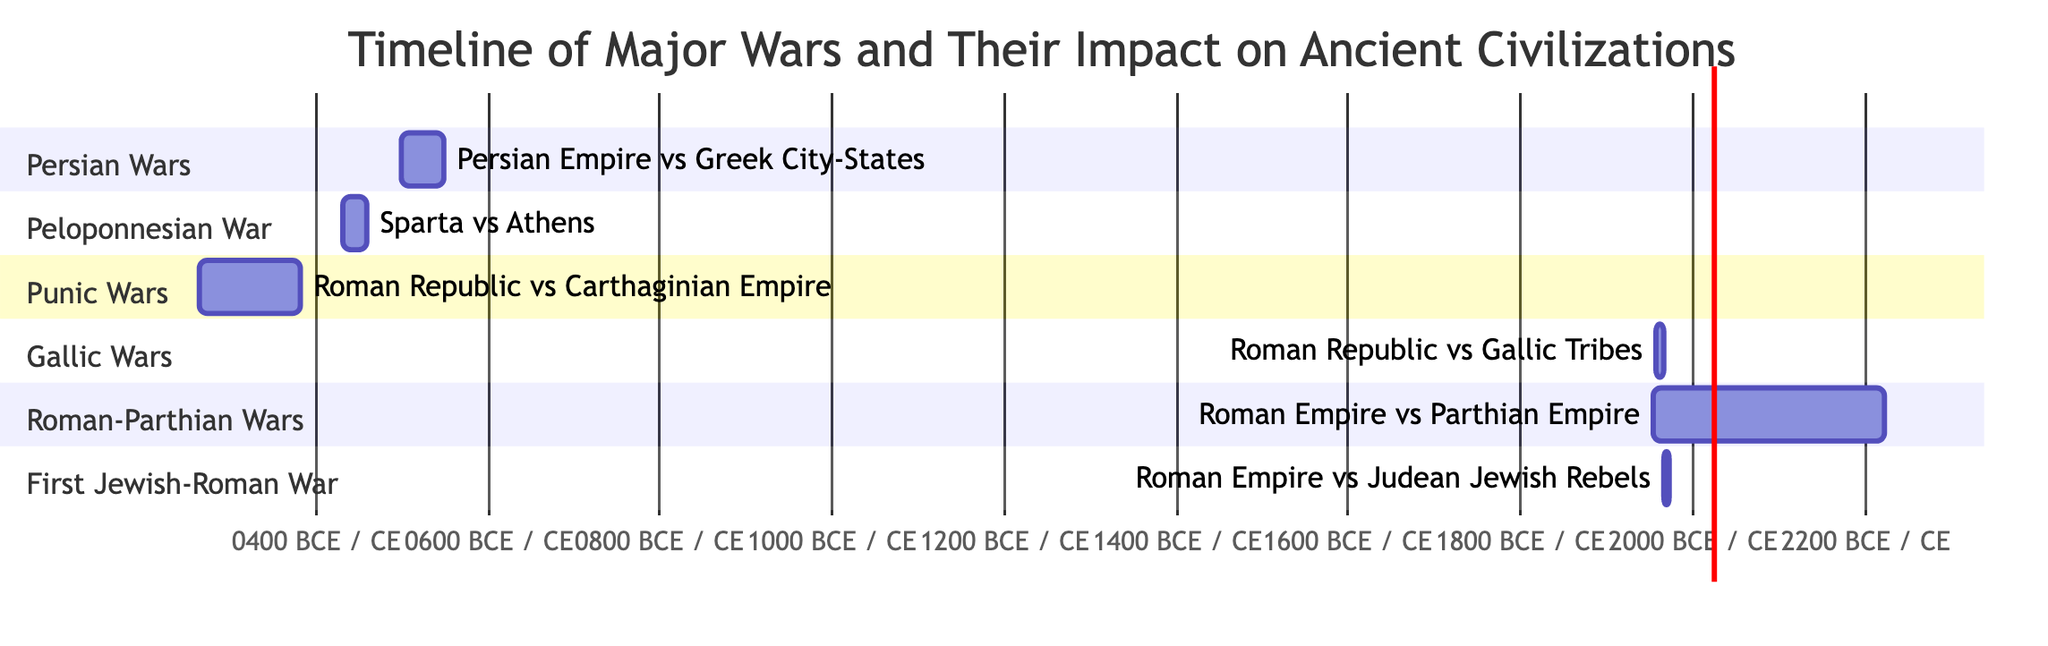What is the duration of the Punic Wars? The Punic Wars lasted from 264 BCE to 146 BCE. To determine the duration, we calculate 264 - 146, which equals 118 years.
Answer: 118 years Which civilizations were involved in the Peloponnesian War? The diagram explicitly states that the civilizations involved in the Peloponnesian War are Sparta and Athens.
Answer: Sparta and Athens When did the First Jewish-Roman War occur? The First Jewish-Roman War started in 66 CE and ended in 73 CE. Thus, it occurred during the years 66 to 73 CE.
Answer: 66 to 73 CE How many years did the Roman-Parthian Wars last? The Roman-Parthian Wars began in 53 BCE and ended in 217 CE. To find the duration, we convert both years into a single scale: the duration is calculated as 217 - (-53) which equals 270 years.
Answer: 270 years Which war led to the rise of Athens? The diagram shows that the Persian Wars led to the rise of Athens as a major power, along with the establishment of the Delian League.
Answer: Persian Wars Which conflict resulted in the destruction of Carthage? According to the impact description of the Punic Wars, this conflict ensured Roman dominance and led to the eventual destruction of Carthage.
Answer: Punic Wars What war marked the end of the Athenian Empire? The diagram indicates that the Peloponnesian War resulted in the fall of the Athenian Empire. Thus, this conflict marked that event.
Answer: Peloponnesian War Which two wars have overlapping periods? Reviewing the diagram, the Roman-Parthian Wars (53 BCE - 217 CE) and the Gallic Wars (58 BCE - 50 BCE) show overlapping periods from 58 BCE to 50 BCE, since the Roman-Parthian Wars started earlier.
Answer: Roman-Parthian Wars and Gallic Wars What was the primary impact of the Gallic Wars? The diagram states the primary impact of the Gallic Wars was the expansion of Roman territory and a solidification of Julius Caesar’s power, paving the way for the end of the Roman Republic.
Answer: Expanded Roman territory and solidified Julius Caesar's power 